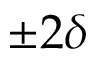Convert formula to latex. <formula><loc_0><loc_0><loc_500><loc_500>\pm 2 \delta</formula> 